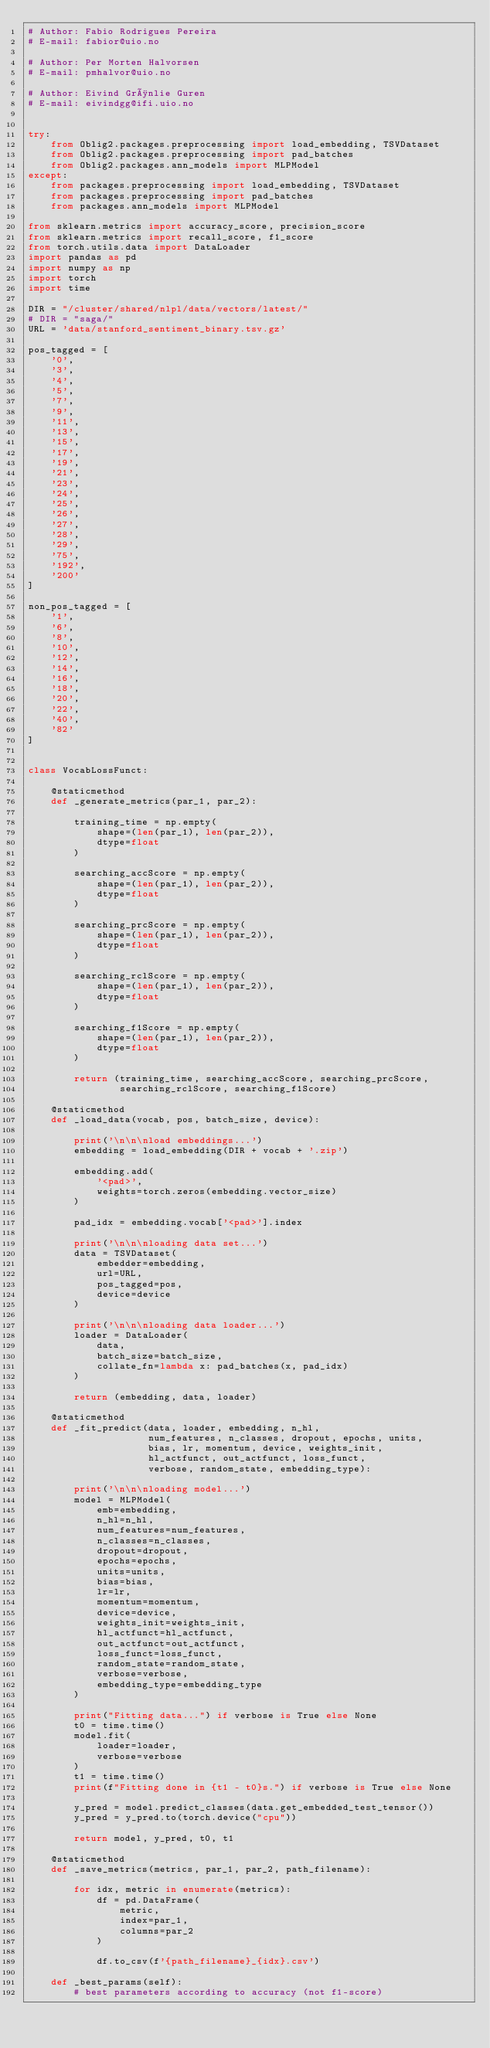Convert code to text. <code><loc_0><loc_0><loc_500><loc_500><_Python_># Author: Fabio Rodrigues Pereira
# E-mail: fabior@uio.no

# Author: Per Morten Halvorsen
# E-mail: pmhalvor@uio.no

# Author: Eivind Grønlie Guren
# E-mail: eivindgg@ifi.uio.no


try:
    from Oblig2.packages.preprocessing import load_embedding, TSVDataset
    from Oblig2.packages.preprocessing import pad_batches
    from Oblig2.packages.ann_models import MLPModel
except:
    from packages.preprocessing import load_embedding, TSVDataset
    from packages.preprocessing import pad_batches
    from packages.ann_models import MLPModel

from sklearn.metrics import accuracy_score, precision_score
from sklearn.metrics import recall_score, f1_score
from torch.utils.data import DataLoader
import pandas as pd
import numpy as np
import torch
import time

DIR = "/cluster/shared/nlpl/data/vectors/latest/"
# DIR = "saga/"
URL = 'data/stanford_sentiment_binary.tsv.gz'

pos_tagged = [
    '0',
    '3',
    '4',
    '5',
    '7',
    '9',
    '11',
    '13',
    '15',
    '17',
    '19',
    '21',
    '23',
    '24',
    '25',
    '26',
    '27',
    '28',
    '29',
    '75',
    '192',
    '200'
]

non_pos_tagged = [
    '1',
    '6',
    '8',
    '10',
    '12',
    '14',
    '16',
    '18',
    '20',
    '22',
    '40',
    '82'
]


class VocabLossFunct:

    @staticmethod
    def _generate_metrics(par_1, par_2):

        training_time = np.empty(
            shape=(len(par_1), len(par_2)),
            dtype=float
        )

        searching_accScore = np.empty(
            shape=(len(par_1), len(par_2)),
            dtype=float
        )

        searching_prcScore = np.empty(
            shape=(len(par_1), len(par_2)),
            dtype=float
        )

        searching_rclScore = np.empty(
            shape=(len(par_1), len(par_2)),
            dtype=float
        )

        searching_f1Score = np.empty(
            shape=(len(par_1), len(par_2)),
            dtype=float
        )

        return (training_time, searching_accScore, searching_prcScore,
                searching_rclScore, searching_f1Score)

    @staticmethod
    def _load_data(vocab, pos, batch_size, device):

        print('\n\n\nload embeddings...')
        embedding = load_embedding(DIR + vocab + '.zip')

        embedding.add(
            '<pad>',
            weights=torch.zeros(embedding.vector_size)
        )

        pad_idx = embedding.vocab['<pad>'].index

        print('\n\n\nloading data set...')
        data = TSVDataset(
            embedder=embedding,
            url=URL,
            pos_tagged=pos,
            device=device
        )

        print('\n\n\nloading data loader...')
        loader = DataLoader(
            data,
            batch_size=batch_size,
            collate_fn=lambda x: pad_batches(x, pad_idx)
        )

        return (embedding, data, loader)

    @staticmethod
    def _fit_predict(data, loader, embedding, n_hl,
                     num_features, n_classes, dropout, epochs, units,
                     bias, lr, momentum, device, weights_init,
                     hl_actfunct, out_actfunct, loss_funct,
                     verbose, random_state, embedding_type):

        print('\n\n\nloading model...')
        model = MLPModel(
            emb=embedding,
            n_hl=n_hl,
            num_features=num_features,
            n_classes=n_classes,
            dropout=dropout,
            epochs=epochs,
            units=units,
            bias=bias,
            lr=lr,
            momentum=momentum,
            device=device,
            weights_init=weights_init,
            hl_actfunct=hl_actfunct,
            out_actfunct=out_actfunct,
            loss_funct=loss_funct,
            random_state=random_state,
            verbose=verbose,
            embedding_type=embedding_type
        )

        print("Fitting data...") if verbose is True else None
        t0 = time.time()
        model.fit(
            loader=loader,
            verbose=verbose
        )
        t1 = time.time()
        print(f"Fitting done in {t1 - t0}s.") if verbose is True else None

        y_pred = model.predict_classes(data.get_embedded_test_tensor())
        y_pred = y_pred.to(torch.device("cpu"))

        return model, y_pred, t0, t1

    @staticmethod
    def _save_metrics(metrics, par_1, par_2, path_filename):

        for idx, metric in enumerate(metrics):
            df = pd.DataFrame(
                metric,
                index=par_1,
                columns=par_2
            )

            df.to_csv(f'{path_filename}_{idx}.csv')

    def _best_params(self):
        # best parameters according to accuracy (not f1-score)</code> 